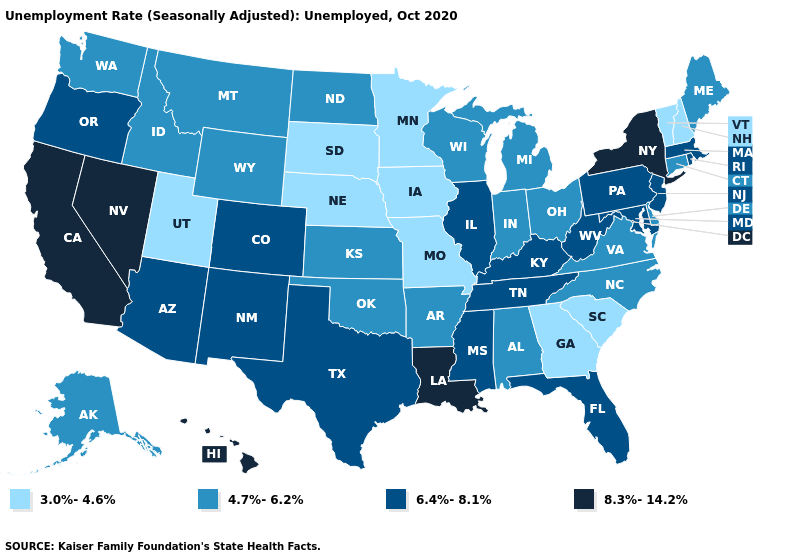Which states hav the highest value in the South?
Short answer required. Louisiana. What is the value of California?
Keep it brief. 8.3%-14.2%. Does Illinois have the lowest value in the USA?
Short answer required. No. Does South Carolina have the highest value in the South?
Give a very brief answer. No. What is the value of Ohio?
Quick response, please. 4.7%-6.2%. Does South Dakota have the lowest value in the USA?
Write a very short answer. Yes. What is the value of Michigan?
Quick response, please. 4.7%-6.2%. Name the states that have a value in the range 6.4%-8.1%?
Be succinct. Arizona, Colorado, Florida, Illinois, Kentucky, Maryland, Massachusetts, Mississippi, New Jersey, New Mexico, Oregon, Pennsylvania, Rhode Island, Tennessee, Texas, West Virginia. Name the states that have a value in the range 6.4%-8.1%?
Quick response, please. Arizona, Colorado, Florida, Illinois, Kentucky, Maryland, Massachusetts, Mississippi, New Jersey, New Mexico, Oregon, Pennsylvania, Rhode Island, Tennessee, Texas, West Virginia. Is the legend a continuous bar?
Concise answer only. No. What is the value of Pennsylvania?
Give a very brief answer. 6.4%-8.1%. Does West Virginia have the highest value in the USA?
Be succinct. No. What is the highest value in the USA?
Give a very brief answer. 8.3%-14.2%. Name the states that have a value in the range 3.0%-4.6%?
Quick response, please. Georgia, Iowa, Minnesota, Missouri, Nebraska, New Hampshire, South Carolina, South Dakota, Utah, Vermont. How many symbols are there in the legend?
Answer briefly. 4. 